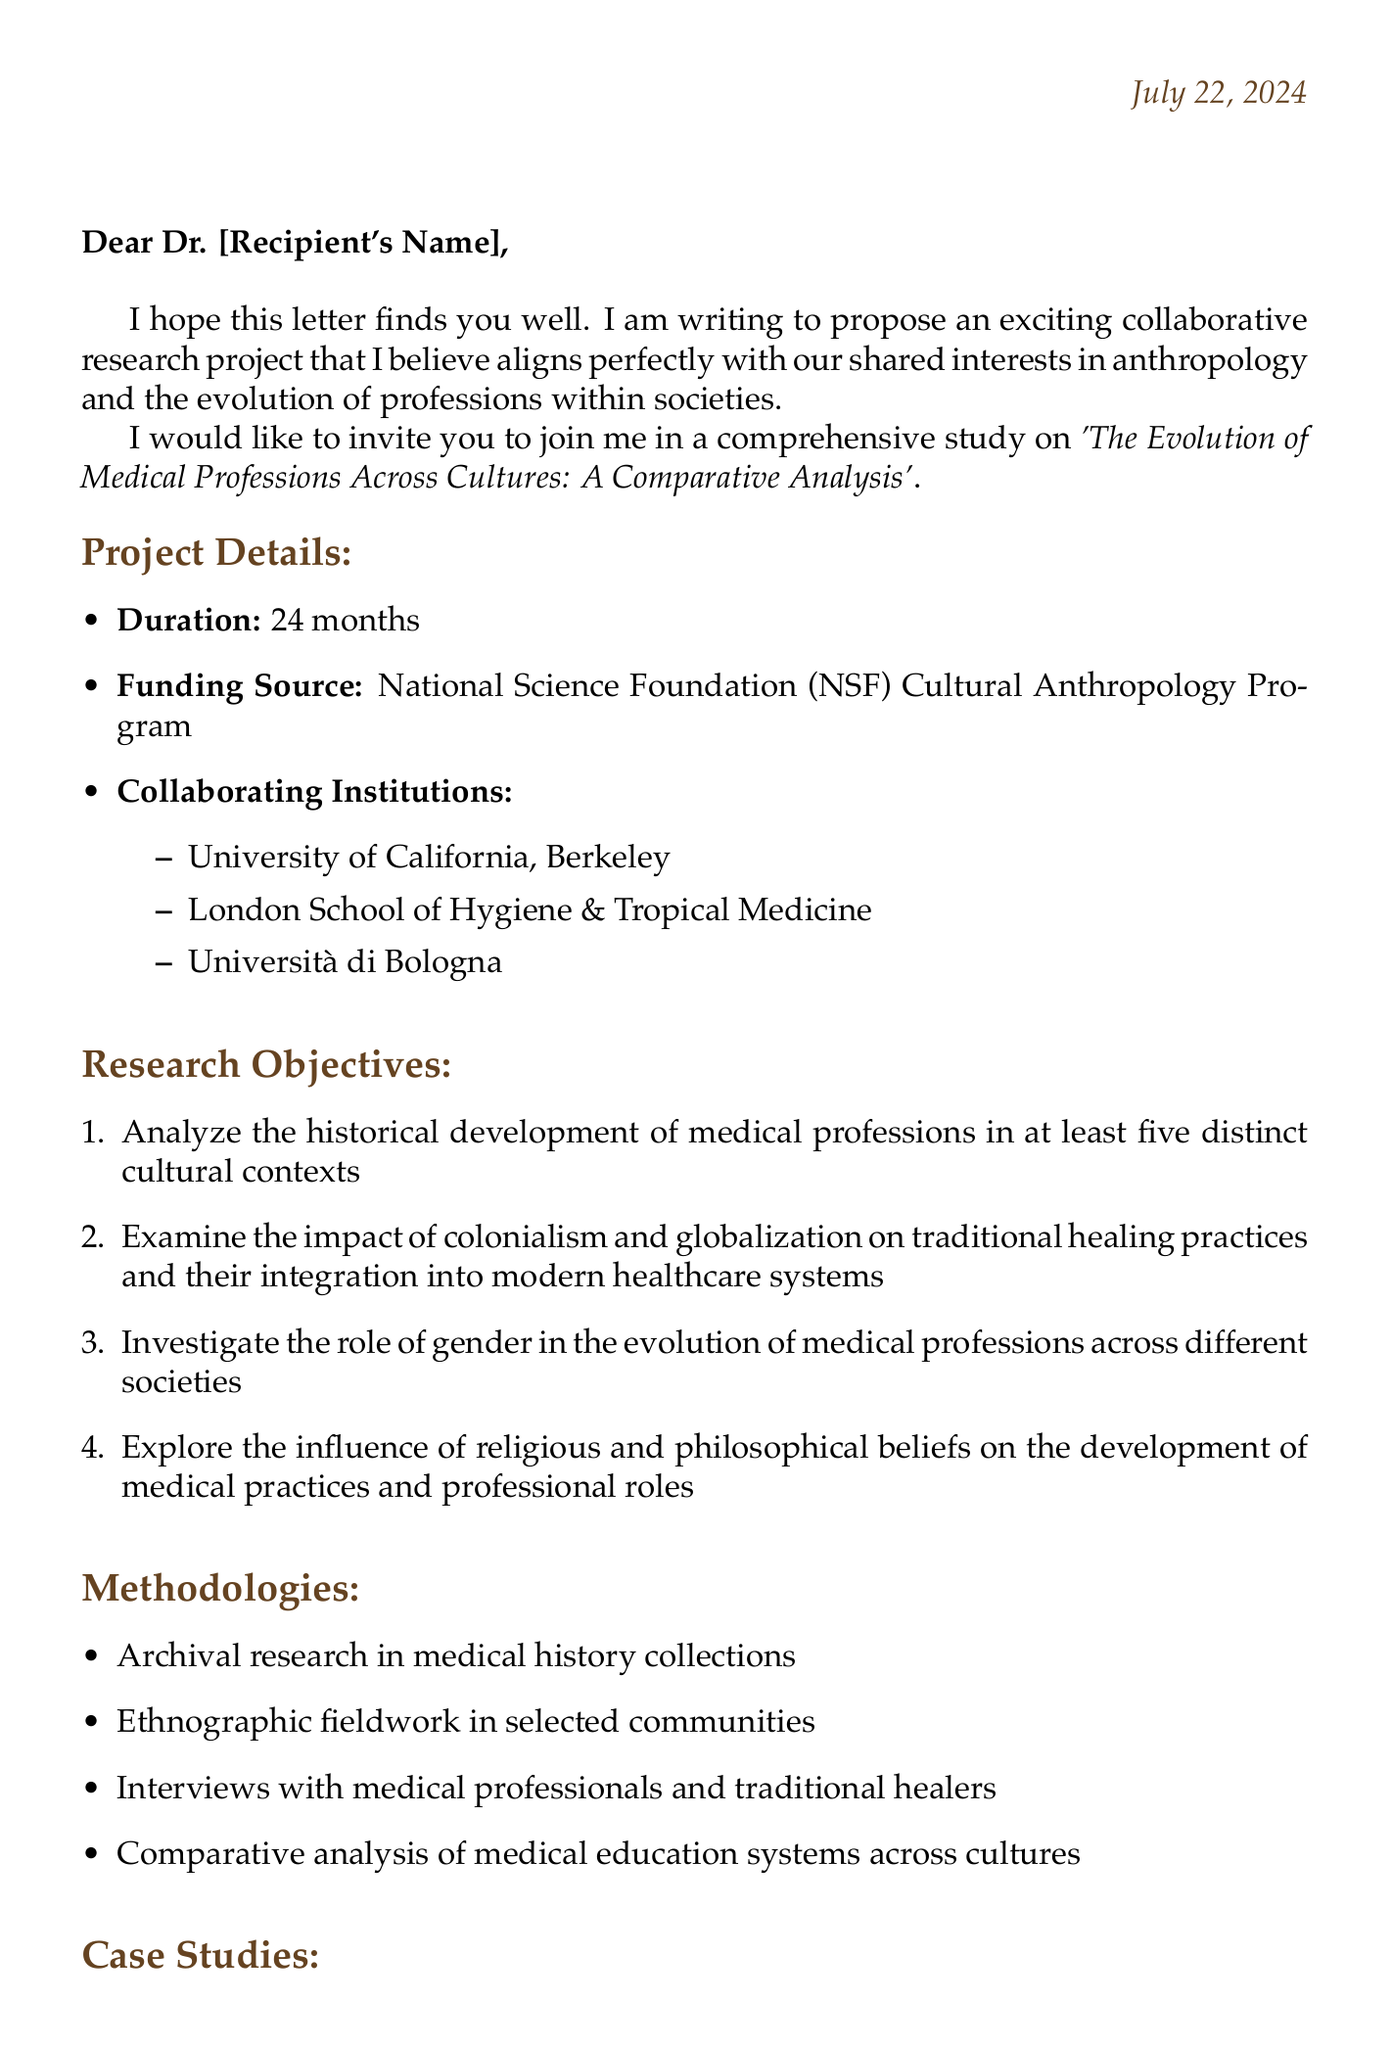What is the proposed title of the research project? The title of the research project is mentioned in the project proposal section of the letter.
Answer: The Evolution of Medical Professions Across Cultures: A Comparative Analysis What is the duration of the project? The duration of the project is specified in the project details section of the letter.
Answer: 24 months Who is the funding source for the project? The funding source is listed in the project details section of the letter.
Answer: National Science Foundation (NSF) Cultural Anthropology Program How many phases are there in the proposed timeline? The proposed timeline describes three distinct phases of the project.
Answer: 3 Which region focuses on the role of traditional birth attendants? This information can be found in the case studies section of the letter.
Answer: West Africa What is the total budget estimate for the project? The total budget is stated in the budget estimate section of the letter.
Answer: $500,000 What methodology involves interviews with medical professionals? The methodologies section describes several approaches to the research, including interviews.
Answer: Interviews with medical professionals and traditional healers What is one of the objectives related to globalization? The research objectives outline the focus areas, including the impact of globalization.
Answer: Examine the impact of colonialism and globalization on traditional healing practices and their integration into modern healthcare systems What kind of literature is referenced in the letter? The letter mentions several authors and titles under the relevant literature section.
Answer: An Anthropology of Biomedicine 